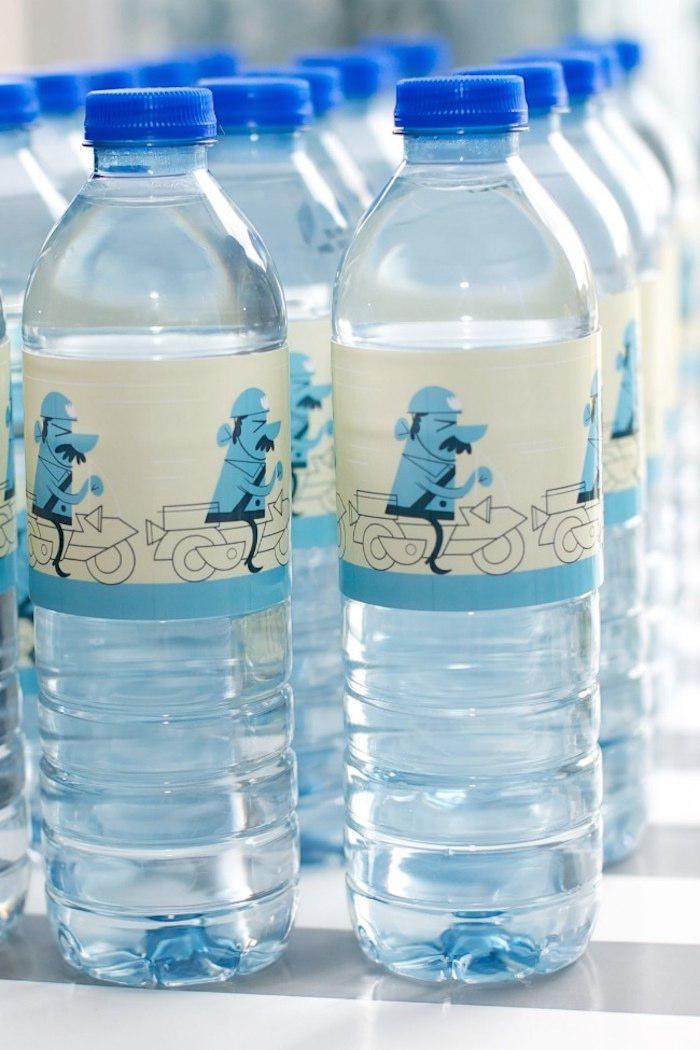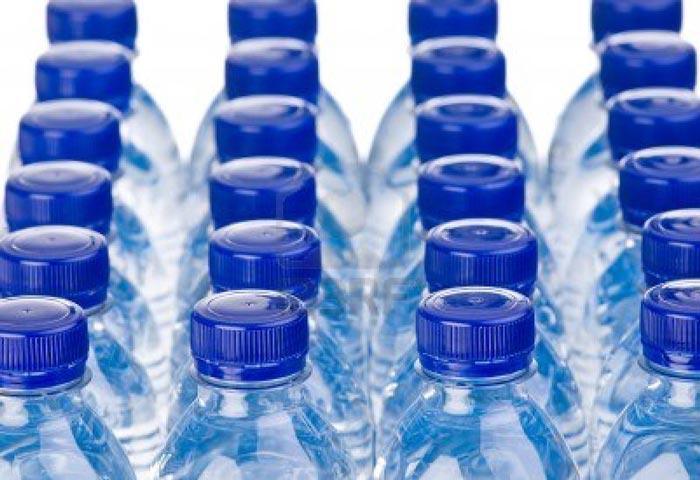The first image is the image on the left, the second image is the image on the right. Evaluate the accuracy of this statement regarding the images: "There is a variety of bottle in one of the images.". Is it true? Answer yes or no. No. 